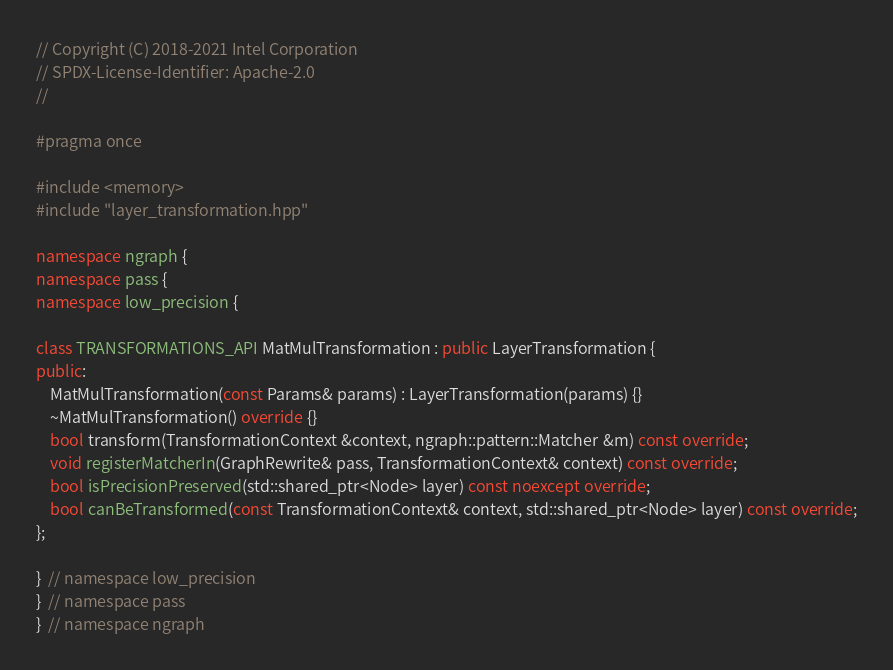Convert code to text. <code><loc_0><loc_0><loc_500><loc_500><_C++_>// Copyright (C) 2018-2021 Intel Corporation
// SPDX-License-Identifier: Apache-2.0
//

#pragma once

#include <memory>
#include "layer_transformation.hpp"

namespace ngraph {
namespace pass {
namespace low_precision {

class TRANSFORMATIONS_API MatMulTransformation : public LayerTransformation {
public:
    MatMulTransformation(const Params& params) : LayerTransformation(params) {}
    ~MatMulTransformation() override {}
    bool transform(TransformationContext &context, ngraph::pattern::Matcher &m) const override;
    void registerMatcherIn(GraphRewrite& pass, TransformationContext& context) const override;
    bool isPrecisionPreserved(std::shared_ptr<Node> layer) const noexcept override;
    bool canBeTransformed(const TransformationContext& context, std::shared_ptr<Node> layer) const override;
};

}  // namespace low_precision
}  // namespace pass
}  // namespace ngraph
</code> 